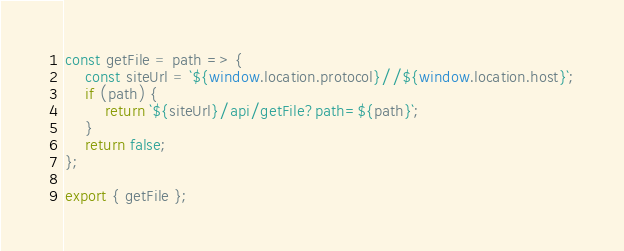<code> <loc_0><loc_0><loc_500><loc_500><_JavaScript_>const getFile = path => {
	const siteUrl = `${window.location.protocol}//${window.location.host}`;
	if (path) {
		return `${siteUrl}/api/getFile?path=${path}`;
	}
	return false;
};

export { getFile };
</code> 